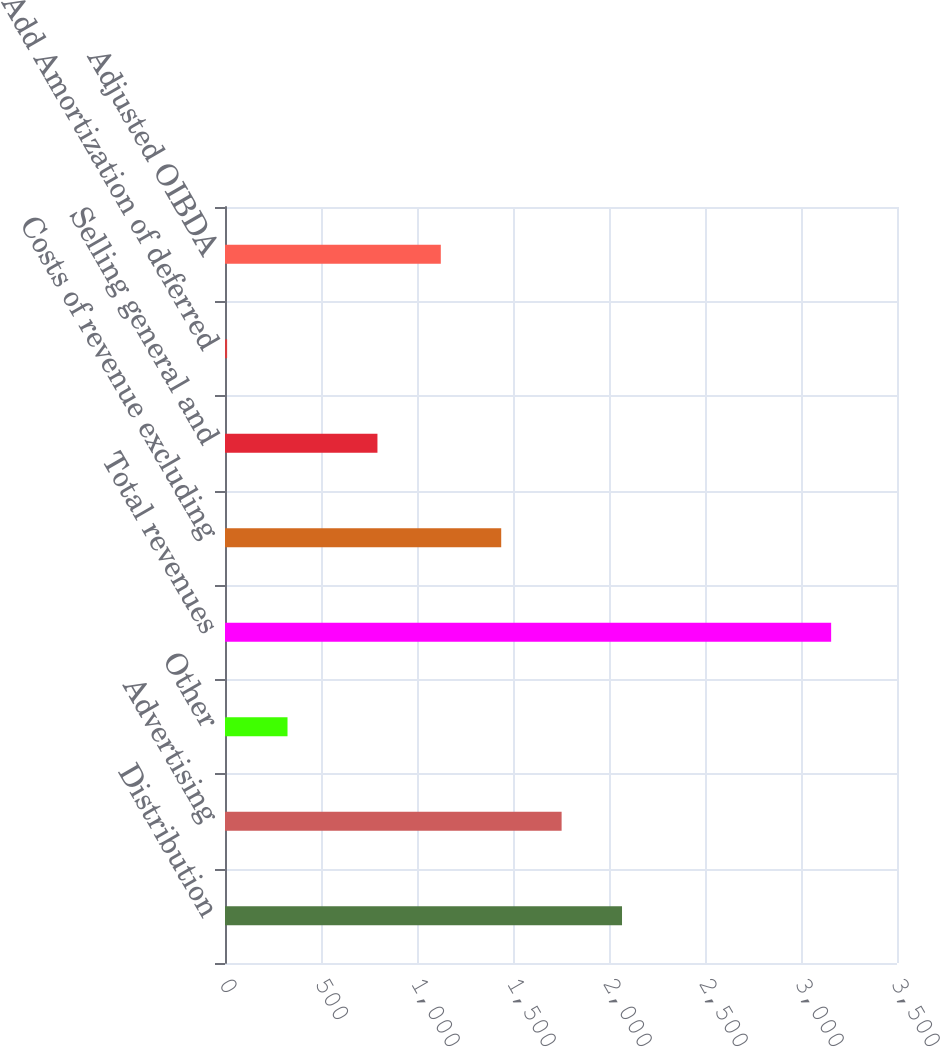Convert chart. <chart><loc_0><loc_0><loc_500><loc_500><bar_chart><fcel>Distribution<fcel>Advertising<fcel>Other<fcel>Total revenues<fcel>Costs of revenue excluding<fcel>Selling general and<fcel>Add Amortization of deferred<fcel>Adjusted OIBDA<nl><fcel>2067.8<fcel>1753.2<fcel>325.6<fcel>3157<fcel>1438.6<fcel>794<fcel>11<fcel>1124<nl></chart> 